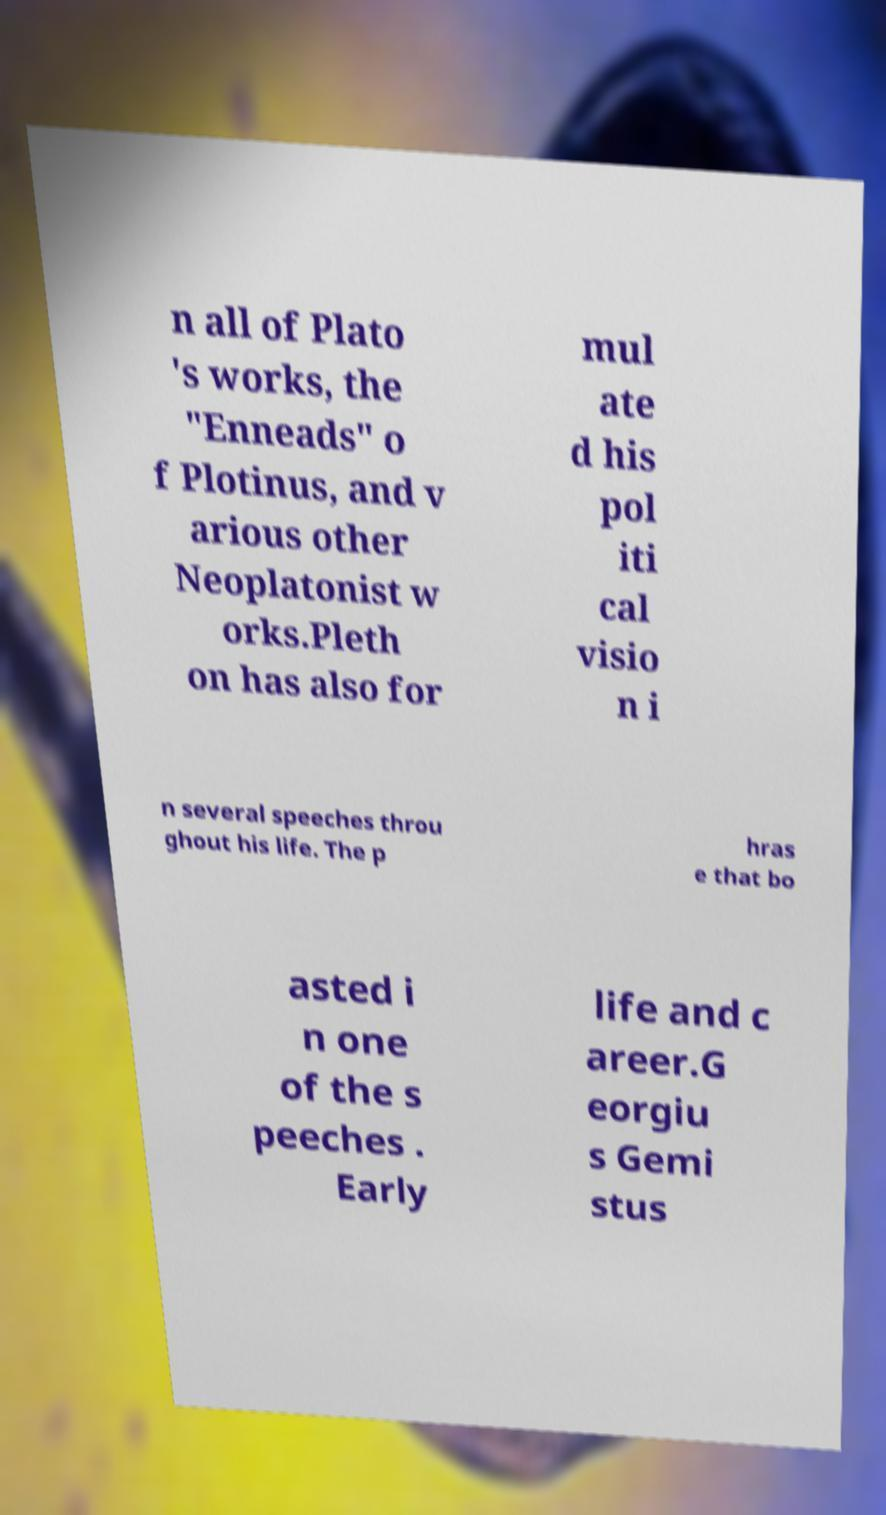For documentation purposes, I need the text within this image transcribed. Could you provide that? n all of Plato 's works, the "Enneads" o f Plotinus, and v arious other Neoplatonist w orks.Pleth on has also for mul ate d his pol iti cal visio n i n several speeches throu ghout his life. The p hras e that bo asted i n one of the s peeches . Early life and c areer.G eorgiu s Gemi stus 